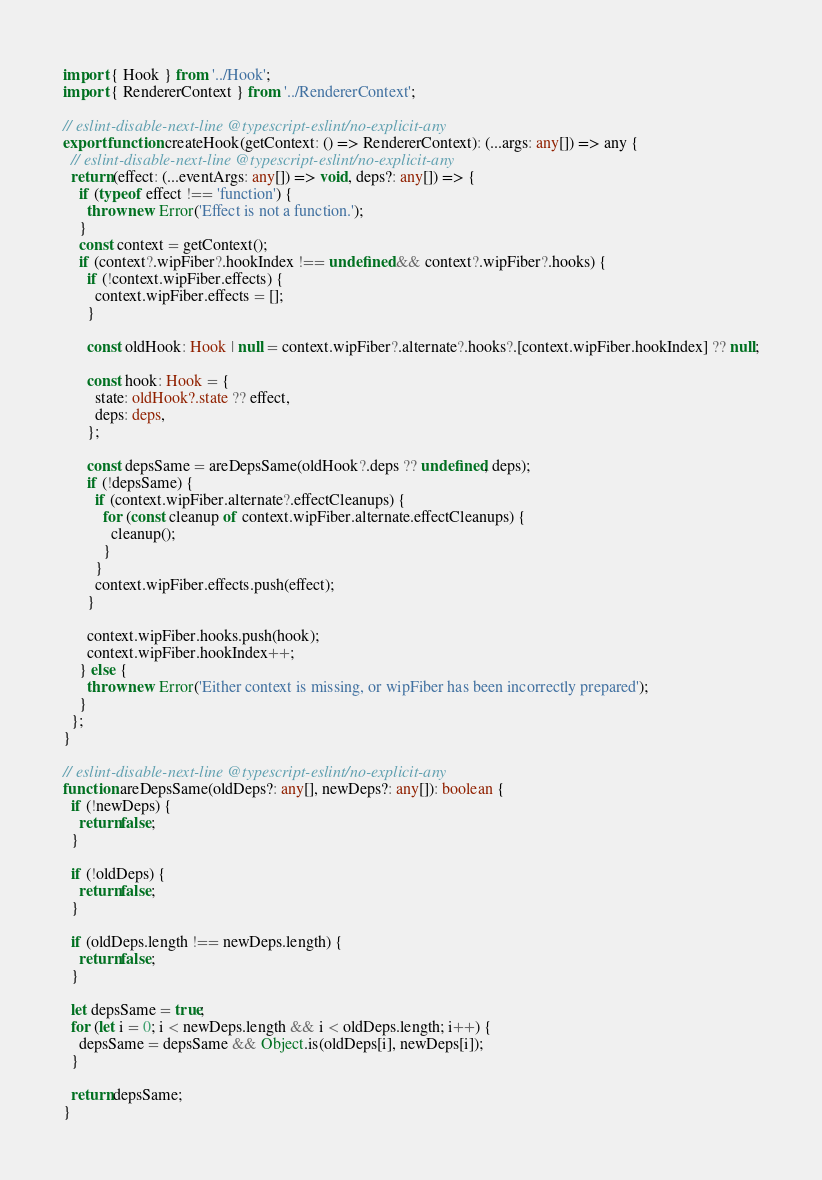<code> <loc_0><loc_0><loc_500><loc_500><_TypeScript_>import { Hook } from '../Hook';
import { RendererContext } from '../RendererContext';

// eslint-disable-next-line @typescript-eslint/no-explicit-any
export function createHook(getContext: () => RendererContext): (...args: any[]) => any {
  // eslint-disable-next-line @typescript-eslint/no-explicit-any
  return (effect: (...eventArgs: any[]) => void, deps?: any[]) => {
    if (typeof effect !== 'function') {
      throw new Error('Effect is not a function.');
    }
    const context = getContext();
    if (context?.wipFiber?.hookIndex !== undefined && context?.wipFiber?.hooks) {
      if (!context.wipFiber.effects) {
        context.wipFiber.effects = [];
      }

      const oldHook: Hook | null = context.wipFiber?.alternate?.hooks?.[context.wipFiber.hookIndex] ?? null;

      const hook: Hook = {
        state: oldHook?.state ?? effect,
        deps: deps,
      };

      const depsSame = areDepsSame(oldHook?.deps ?? undefined, deps);
      if (!depsSame) {
        if (context.wipFiber.alternate?.effectCleanups) {
          for (const cleanup of context.wipFiber.alternate.effectCleanups) {
            cleanup();
          }
        }
        context.wipFiber.effects.push(effect);
      }

      context.wipFiber.hooks.push(hook);
      context.wipFiber.hookIndex++;
    } else {
      throw new Error('Either context is missing, or wipFiber has been incorrectly prepared');
    }
  };
}

// eslint-disable-next-line @typescript-eslint/no-explicit-any
function areDepsSame(oldDeps?: any[], newDeps?: any[]): boolean {
  if (!newDeps) {
    return false;
  }

  if (!oldDeps) {
    return false;
  }

  if (oldDeps.length !== newDeps.length) {
    return false;
  }

  let depsSame = true;
  for (let i = 0; i < newDeps.length && i < oldDeps.length; i++) {
    depsSame = depsSame && Object.is(oldDeps[i], newDeps[i]);
  }

  return depsSame;
}
</code> 